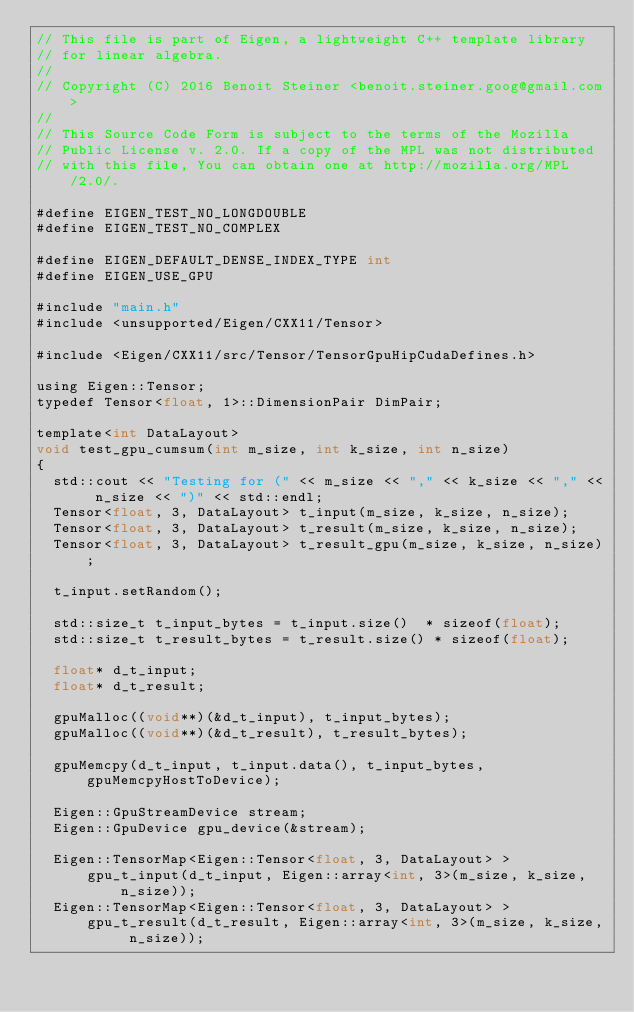<code> <loc_0><loc_0><loc_500><loc_500><_Cuda_>// This file is part of Eigen, a lightweight C++ template library
// for linear algebra.
//
// Copyright (C) 2016 Benoit Steiner <benoit.steiner.goog@gmail.com>
//
// This Source Code Form is subject to the terms of the Mozilla
// Public License v. 2.0. If a copy of the MPL was not distributed
// with this file, You can obtain one at http://mozilla.org/MPL/2.0/.

#define EIGEN_TEST_NO_LONGDOUBLE
#define EIGEN_TEST_NO_COMPLEX

#define EIGEN_DEFAULT_DENSE_INDEX_TYPE int
#define EIGEN_USE_GPU

#include "main.h"
#include <unsupported/Eigen/CXX11/Tensor>

#include <Eigen/CXX11/src/Tensor/TensorGpuHipCudaDefines.h>

using Eigen::Tensor;
typedef Tensor<float, 1>::DimensionPair DimPair;

template<int DataLayout>
void test_gpu_cumsum(int m_size, int k_size, int n_size)
{
  std::cout << "Testing for (" << m_size << "," << k_size << "," << n_size << ")" << std::endl;
  Tensor<float, 3, DataLayout> t_input(m_size, k_size, n_size);
  Tensor<float, 3, DataLayout> t_result(m_size, k_size, n_size);
  Tensor<float, 3, DataLayout> t_result_gpu(m_size, k_size, n_size);

  t_input.setRandom();

  std::size_t t_input_bytes = t_input.size()  * sizeof(float);
  std::size_t t_result_bytes = t_result.size() * sizeof(float);

  float* d_t_input;
  float* d_t_result;

  gpuMalloc((void**)(&d_t_input), t_input_bytes);
  gpuMalloc((void**)(&d_t_result), t_result_bytes);

  gpuMemcpy(d_t_input, t_input.data(), t_input_bytes, gpuMemcpyHostToDevice);

  Eigen::GpuStreamDevice stream;
  Eigen::GpuDevice gpu_device(&stream);

  Eigen::TensorMap<Eigen::Tensor<float, 3, DataLayout> >
      gpu_t_input(d_t_input, Eigen::array<int, 3>(m_size, k_size, n_size));
  Eigen::TensorMap<Eigen::Tensor<float, 3, DataLayout> >
      gpu_t_result(d_t_result, Eigen::array<int, 3>(m_size, k_size, n_size));
</code> 